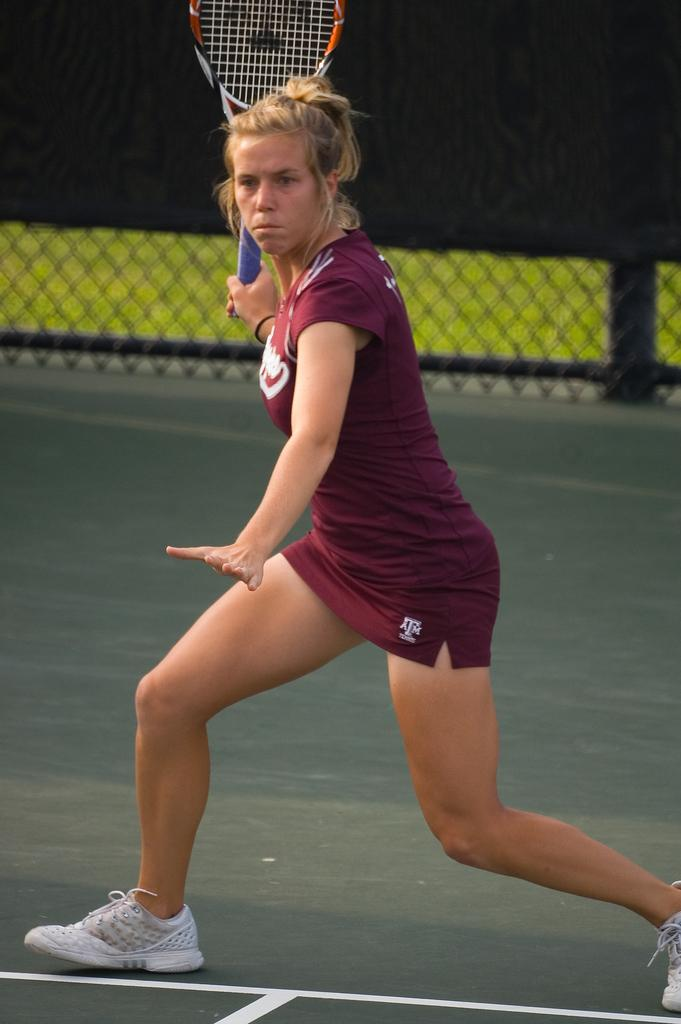Who is the main subject in the image? There is a woman in the image. What is the woman doing in the image? The woman is playing tennis. What equipment is the woman using to play tennis? The woman is using a tennis bat. Can you see a ghost holding a toothbrush in the image? No, there is no ghost or toothbrush present in the image. 